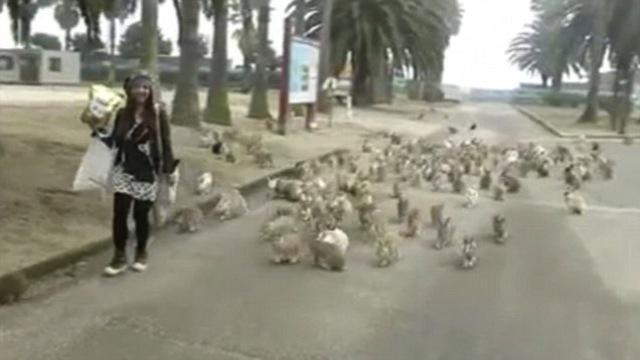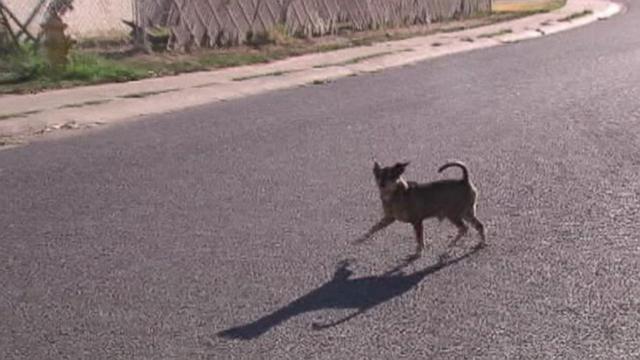The first image is the image on the left, the second image is the image on the right. Assess this claim about the two images: "A person walks toward the camera near a pack of small animals that walk on the same paved surface.". Correct or not? Answer yes or no. Yes. 